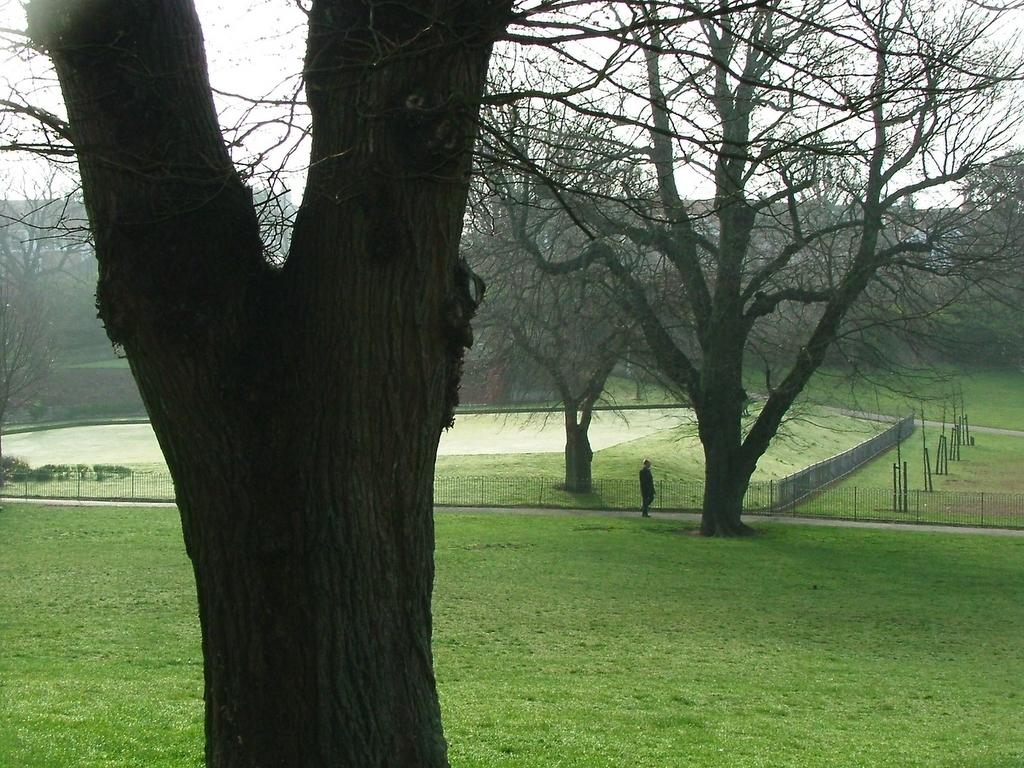What is the person in the image doing? The person is standing on the road. What type of vegetation can be seen in the image? There are trees, grass, and plants in the image. What structures are present in the image? There are poles and buildings in the image. What is the boundary element in the image? There is a fence in the image. What part of the natural environment is visible in the background of the image? The sky is visible in the background of the image. What flavor of ice cream is the person holding in the image? There is no ice cream present in the image, so it is not possible to determine the flavor. 